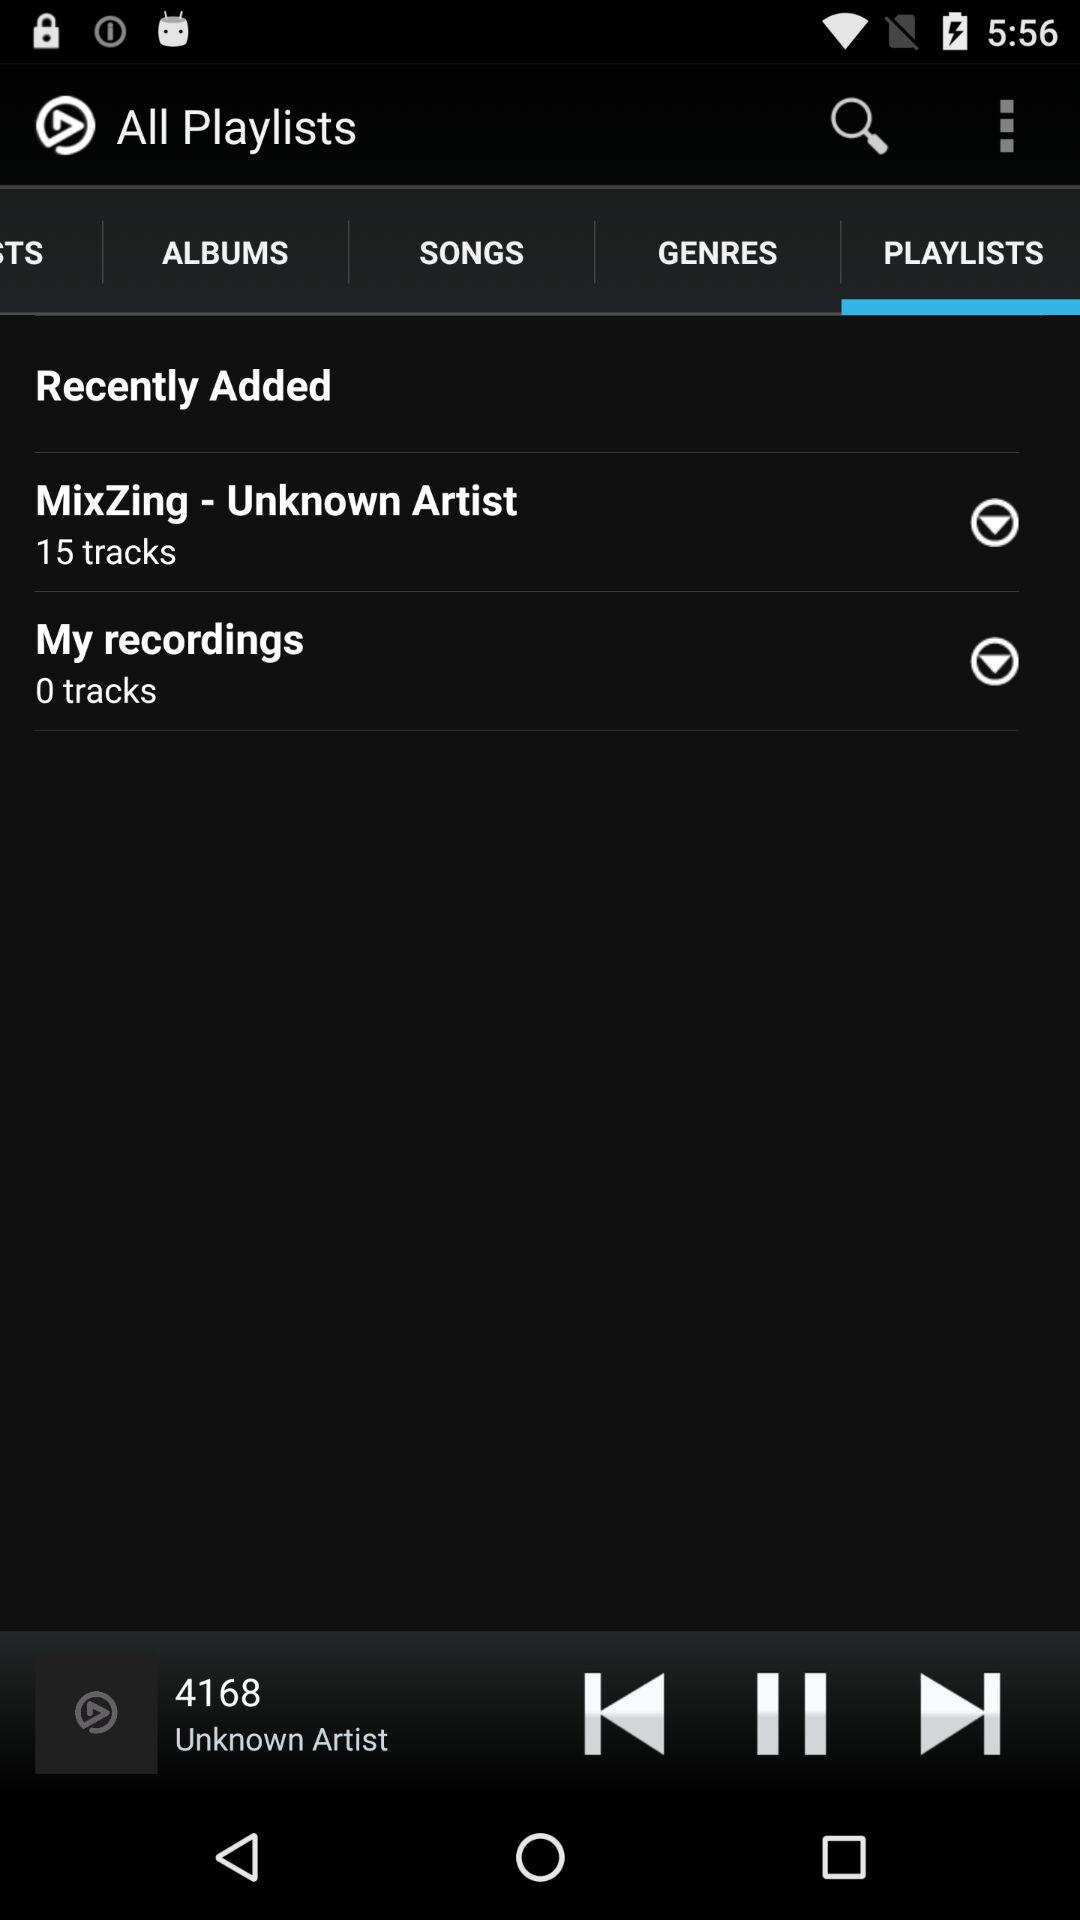What are the playlists available? The playlists available are: "MixZing - Unknown Artists" and "My recordings". 